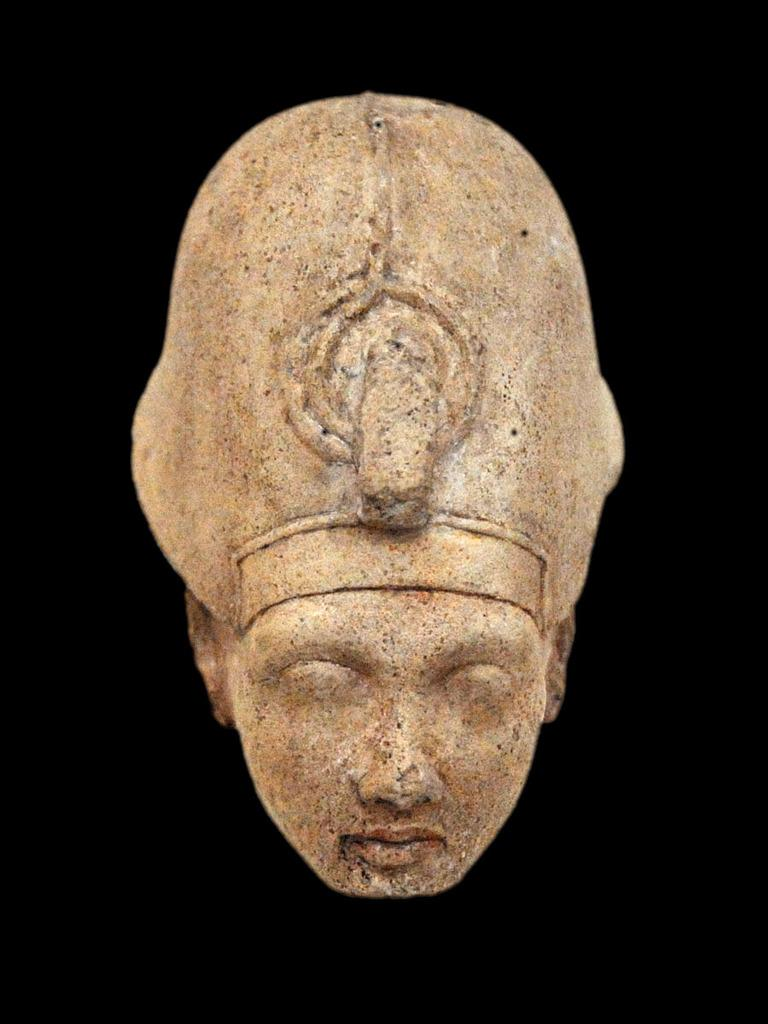What is the main subject in the image? There is a cream-colored sculpture in the image. Where is the sculpture located in relation to the image? The sculpture is in the front of the image. What color can be seen in the background of the image? There is black color visible in the background of the image. What type of punishment is being given to the bee in the image? There is no bee present in the image, so no punishment can be observed. 